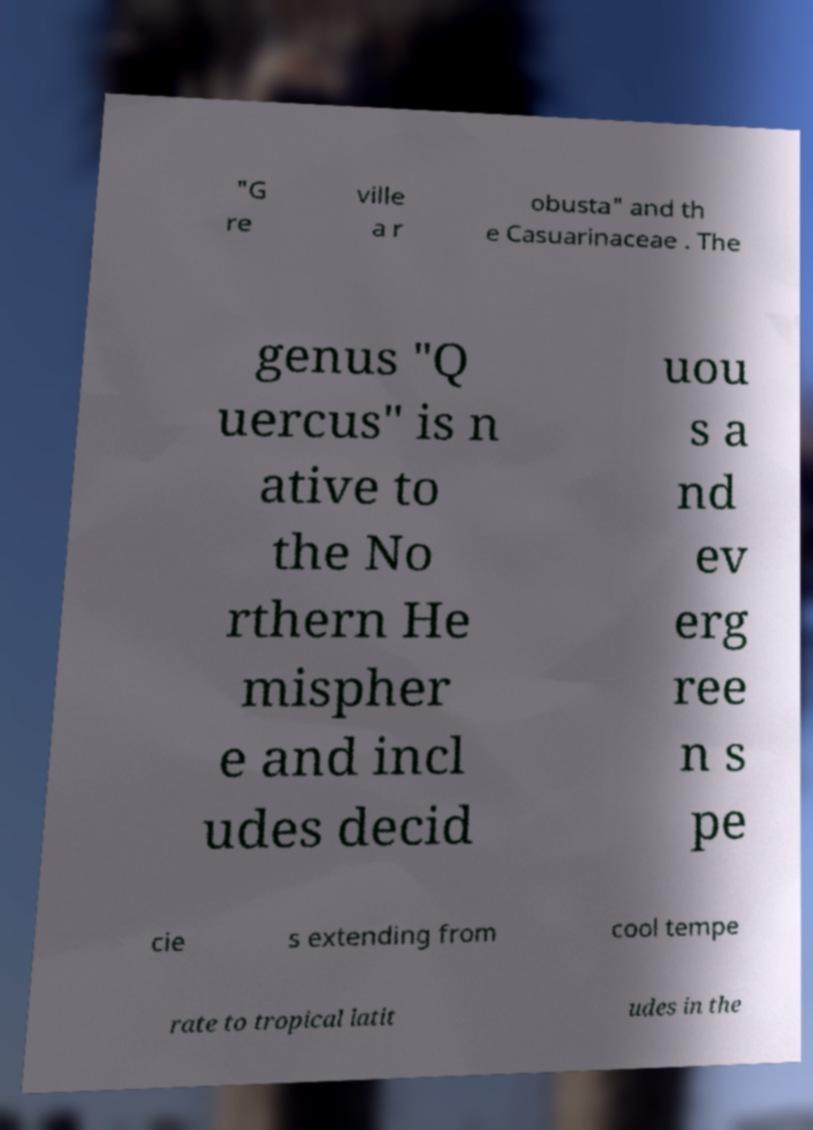For documentation purposes, I need the text within this image transcribed. Could you provide that? "G re ville a r obusta" and th e Casuarinaceae . The genus "Q uercus" is n ative to the No rthern He mispher e and incl udes decid uou s a nd ev erg ree n s pe cie s extending from cool tempe rate to tropical latit udes in the 